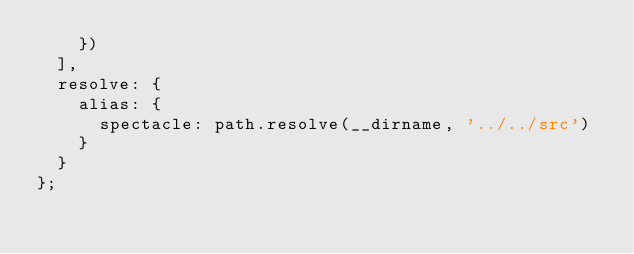Convert code to text. <code><loc_0><loc_0><loc_500><loc_500><_JavaScript_>    })
  ],
  resolve: {
    alias: {
      spectacle: path.resolve(__dirname, '../../src')
    }
  }
};
</code> 